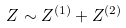Convert formula to latex. <formula><loc_0><loc_0><loc_500><loc_500>Z \sim Z ^ { ( 1 ) } + Z ^ { ( 2 ) } \,</formula> 